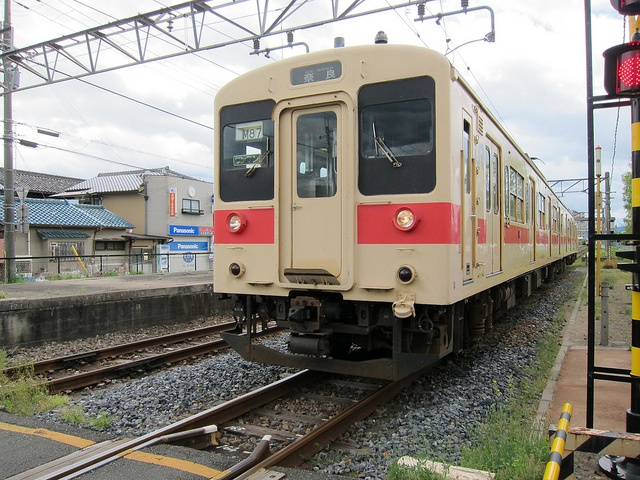Describe the objects in this image and their specific colors. I can see train in lightgray, black, tan, and gray tones and traffic light in lightgray, black, brown, and maroon tones in this image. 